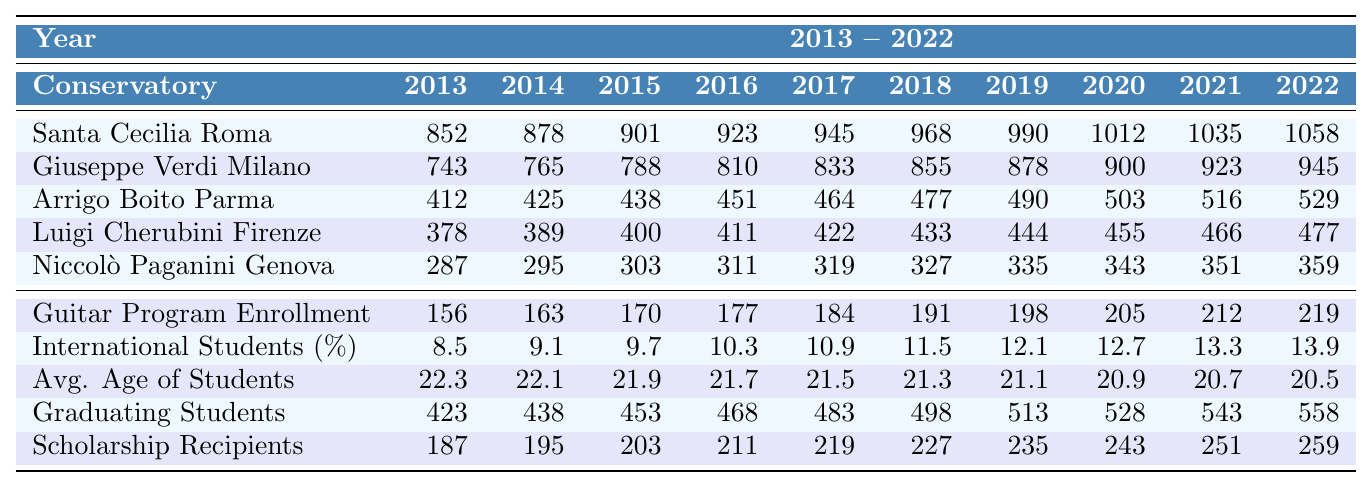What was the enrollment in the Guitar Program in 2018? The table shows that the Guitar Program Enrollment for 2018 is 191.
Answer: 191 How many students graduated in 2022? The table indicates that the number of graduating students in 2022 is 558.
Answer: 558 Which conservatory had the highest enrollment in 2019? By comparing the enrollment numbers in 2019, Santa Cecilia Roma had the highest with 990 students.
Answer: Santa Cecilia Roma What is the percentage increase in the number of international students from 2013 to 2022? The percentage of international students increased from 8.5% in 2013 to 13.9% in 2022. The increase is 13.9 - 8.5 = 5.4%.
Answer: 5.4% True or False: The average age of enrolled students decreased over the past decade. The data shows that the average age of enrolled students decreased from 22.3 in 2013 to 20.5 in 2022, indicating a consistent decline.
Answer: True What is the total number of students enrolled across all conservatories in 2021? Summing the enrollment numbers from each conservatory for the year 2021 gives: 1035 (Santa Cecilia) + 923 (Giuseppe Verdi) + 516 (Arrigo Boito) + 466 (Luigi Cherubini) + 351 (Niccolò Paganini) = 3291.
Answer: 3291 Which conservatory experienced the smallest enrollment in 2014? Reviewing the 2014 data, Niccolò Paganini Genova had the smallest enrollment of 295 students.
Answer: Niccolò Paganini Genova How many more scholarship recipients were there in 2022 than in 2013? The number of scholarship recipients in 2022 is 259, while in 2013 it was 187. The difference is 259 - 187 = 72.
Answer: 72 What was the average enrollment across all conservatories in 2017? The total enrollment for 2017 from the conservatories is 945 + 833 + 464 + 422 + 319 = 3003. Dividing this by the number of conservatories (5): 3003 / 5 = 600.6.
Answer: 600.6 Did the enrollment in the Guitar Program ever exceed 210 students during this decade? By checking the Guitar Program Enrollment row, the highest recorded enrollment in 2022 is 219 students, confirming it exceeded 210.
Answer: Yes What was the trend in the average age of enrolled students over the decade? The data shows that the average age decreased from 22.3 in 2013 to 20.5 in 2022, indicating a downward trend.
Answer: Decreasing 